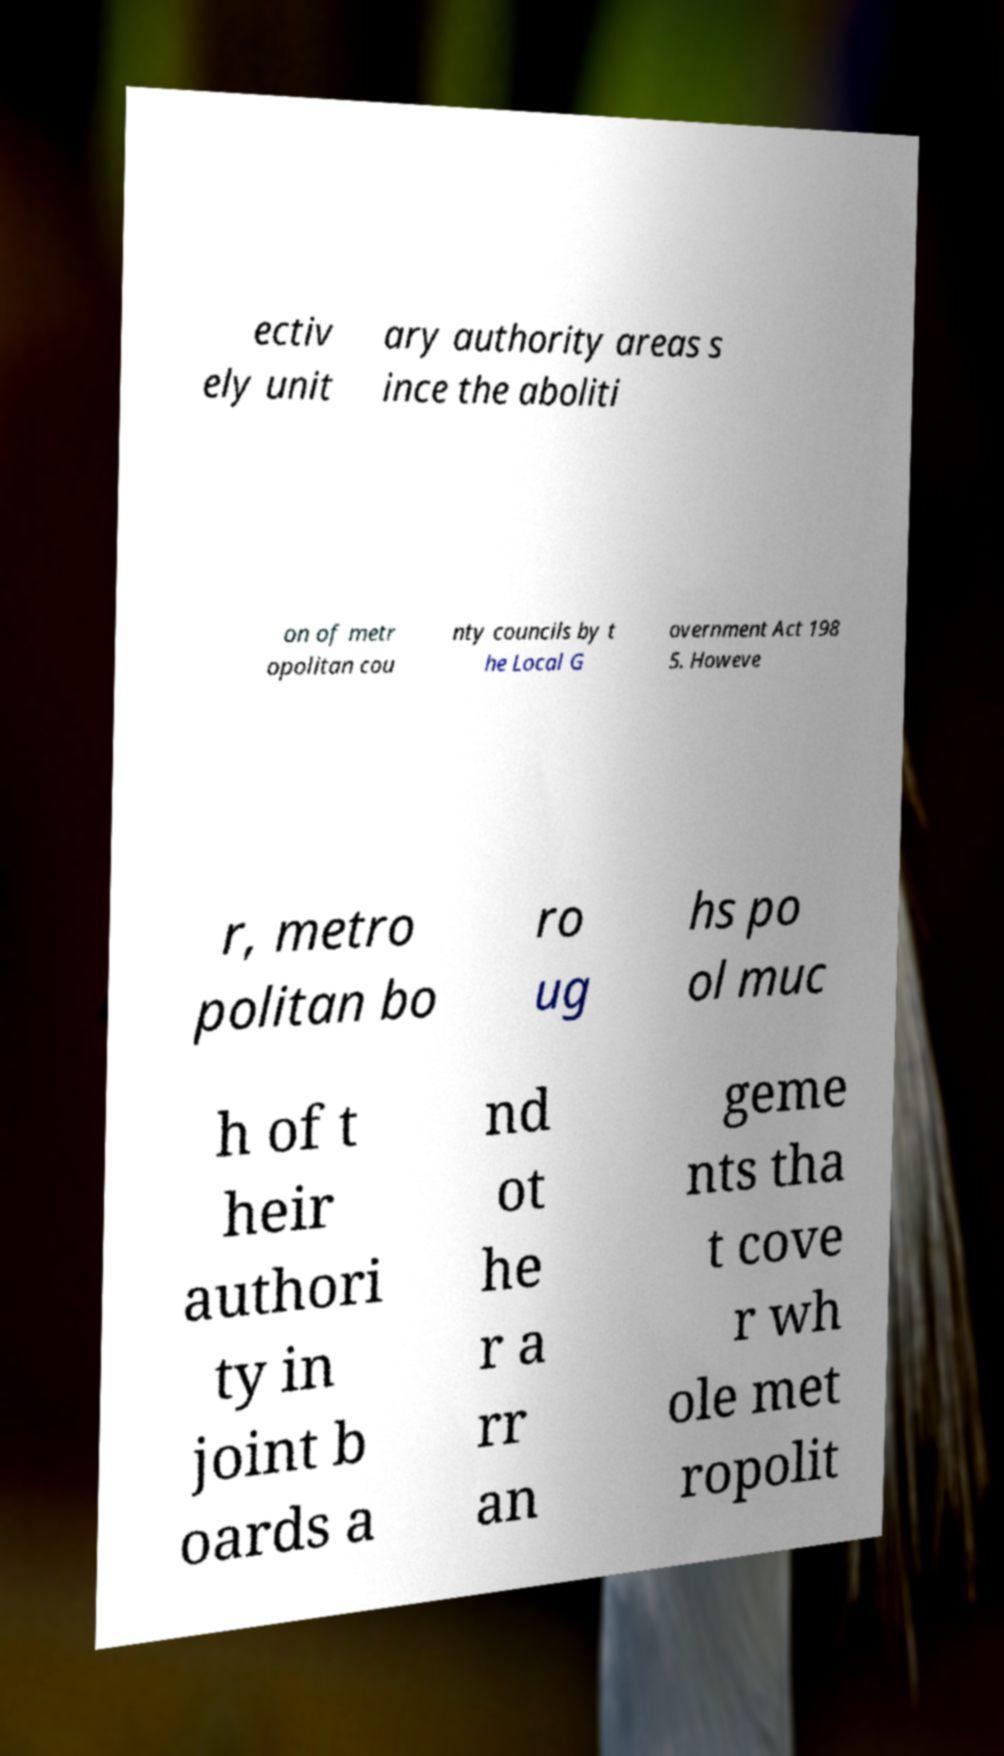Can you read and provide the text displayed in the image?This photo seems to have some interesting text. Can you extract and type it out for me? ectiv ely unit ary authority areas s ince the aboliti on of metr opolitan cou nty councils by t he Local G overnment Act 198 5. Howeve r, metro politan bo ro ug hs po ol muc h of t heir authori ty in joint b oards a nd ot he r a rr an geme nts tha t cove r wh ole met ropolit 